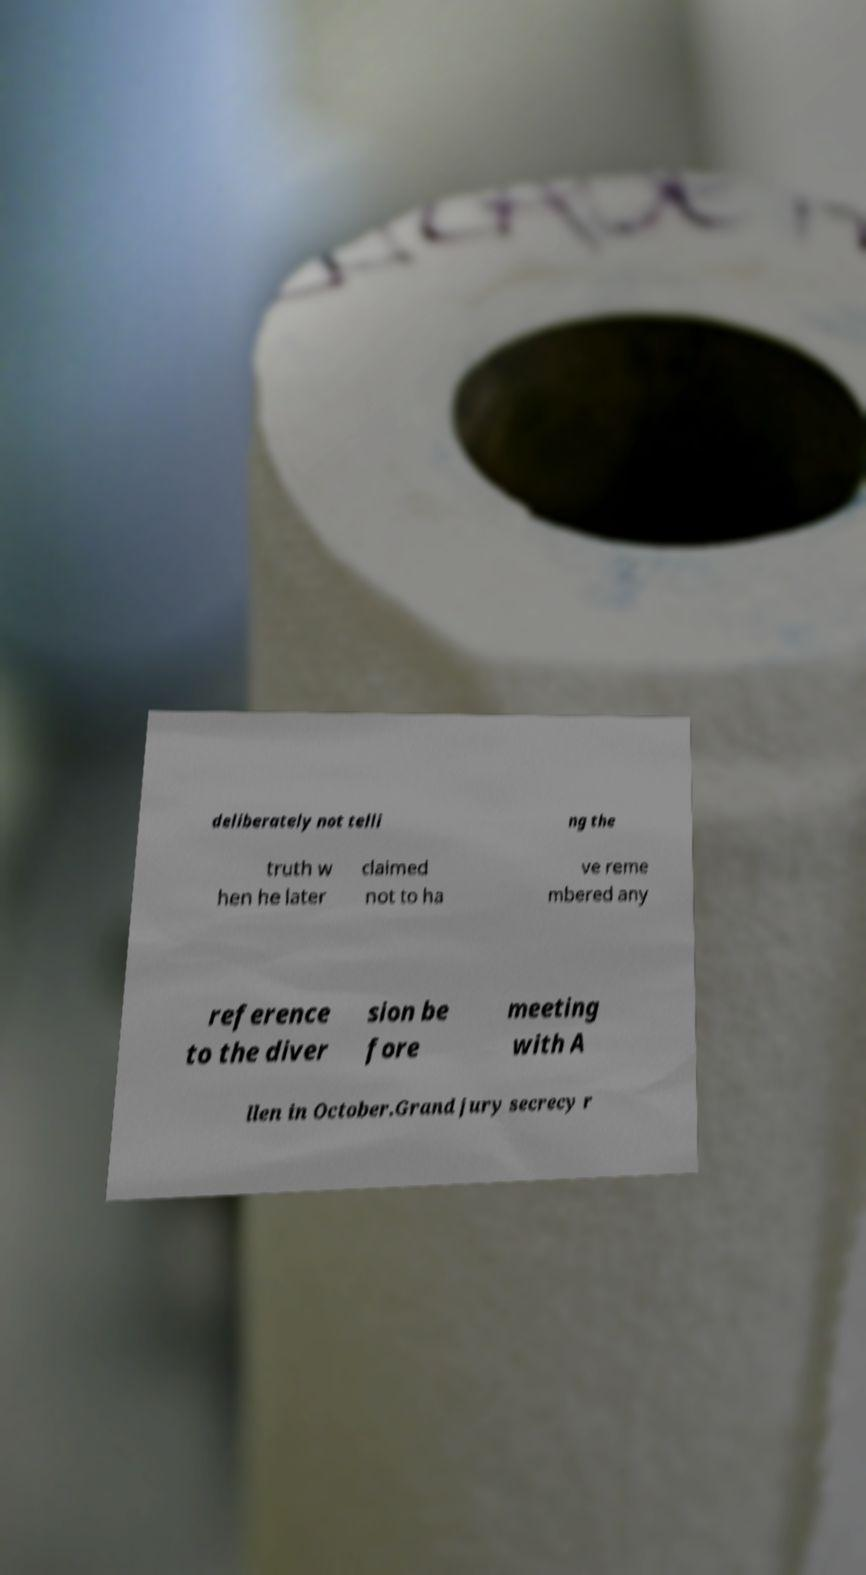Could you assist in decoding the text presented in this image and type it out clearly? deliberately not telli ng the truth w hen he later claimed not to ha ve reme mbered any reference to the diver sion be fore meeting with A llen in October.Grand jury secrecy r 